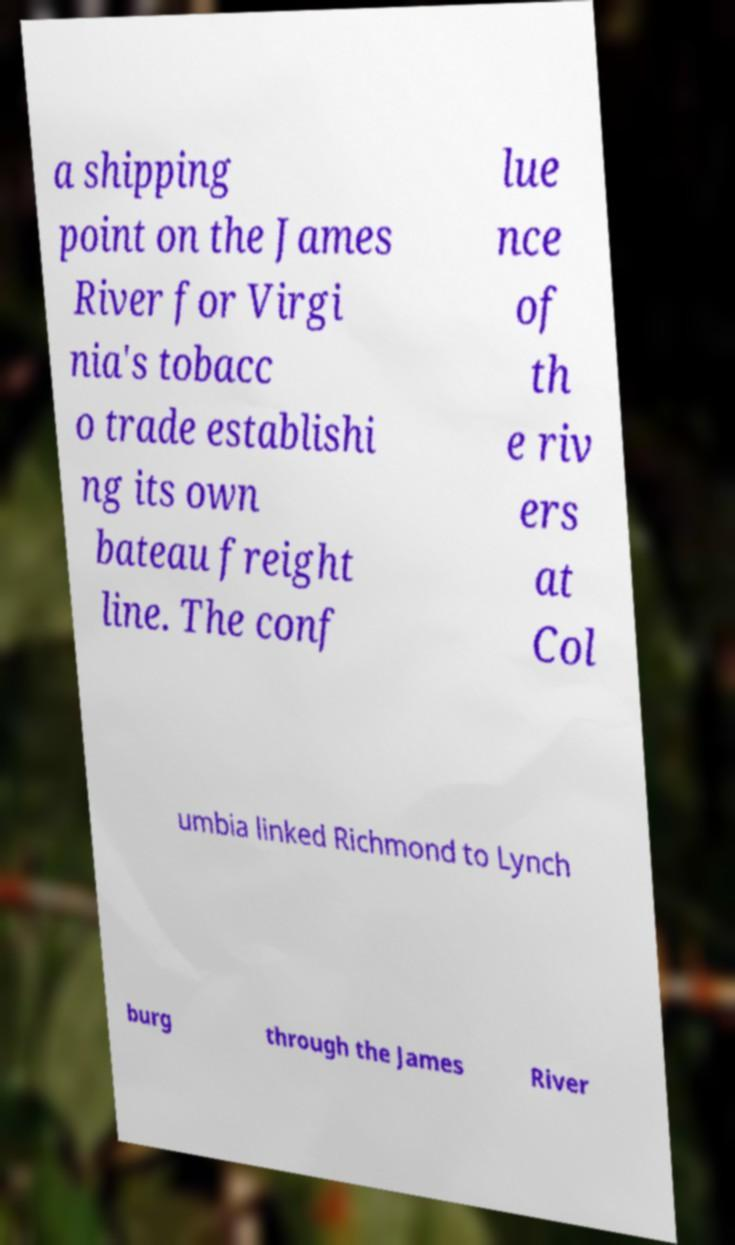I need the written content from this picture converted into text. Can you do that? a shipping point on the James River for Virgi nia's tobacc o trade establishi ng its own bateau freight line. The conf lue nce of th e riv ers at Col umbia linked Richmond to Lynch burg through the James River 